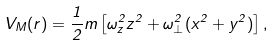<formula> <loc_0><loc_0><loc_500><loc_500>V _ { M } ( r ) = \frac { 1 } { 2 } m \left [ \omega _ { z } ^ { 2 } z ^ { 2 } + \omega _ { \perp } ^ { 2 } ( x ^ { 2 } + y ^ { 2 } ) \right ] ,</formula> 